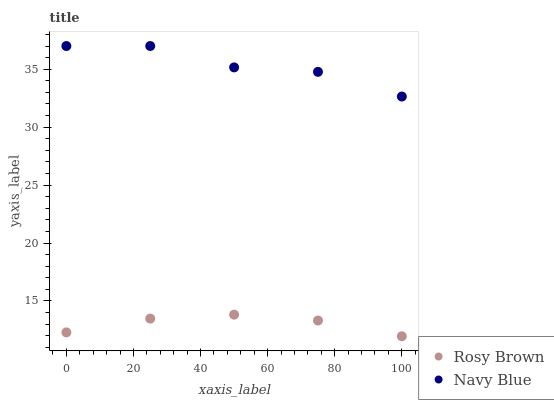Does Rosy Brown have the minimum area under the curve?
Answer yes or no. Yes. Does Navy Blue have the maximum area under the curve?
Answer yes or no. Yes. Does Rosy Brown have the maximum area under the curve?
Answer yes or no. No. Is Rosy Brown the smoothest?
Answer yes or no. Yes. Is Navy Blue the roughest?
Answer yes or no. Yes. Is Rosy Brown the roughest?
Answer yes or no. No. Does Rosy Brown have the lowest value?
Answer yes or no. Yes. Does Navy Blue have the highest value?
Answer yes or no. Yes. Does Rosy Brown have the highest value?
Answer yes or no. No. Is Rosy Brown less than Navy Blue?
Answer yes or no. Yes. Is Navy Blue greater than Rosy Brown?
Answer yes or no. Yes. Does Rosy Brown intersect Navy Blue?
Answer yes or no. No. 